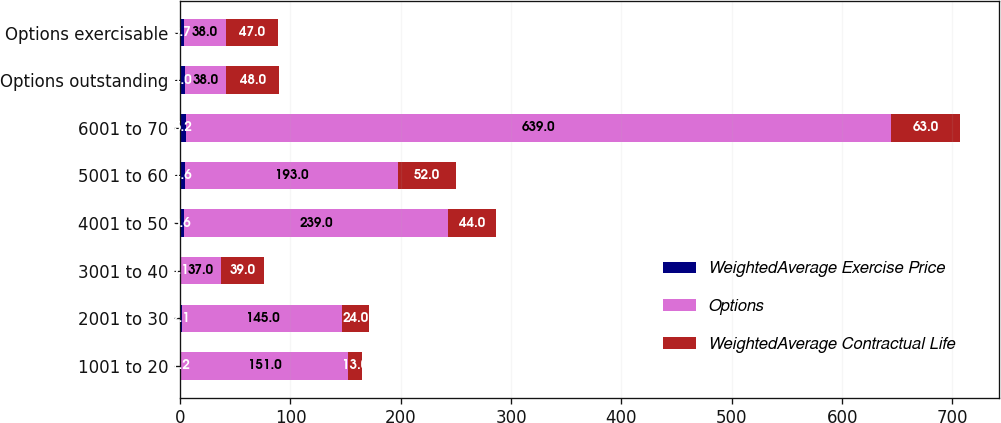Convert chart to OTSL. <chart><loc_0><loc_0><loc_500><loc_500><stacked_bar_chart><ecel><fcel>1001 to 20<fcel>2001 to 30<fcel>3001 to 40<fcel>4001 to 50<fcel>5001 to 60<fcel>6001 to 70<fcel>Options outstanding<fcel>Options exercisable<nl><fcel>WeightedAverage Exercise Price<fcel>1.2<fcel>2.1<fcel>0.1<fcel>3.6<fcel>4.6<fcel>5.2<fcel>4<fcel>3.7<nl><fcel>Options<fcel>151<fcel>145<fcel>37<fcel>239<fcel>193<fcel>639<fcel>38<fcel>38<nl><fcel>WeightedAverage Contractual Life<fcel>13<fcel>24<fcel>39<fcel>44<fcel>52<fcel>63<fcel>48<fcel>47<nl></chart> 